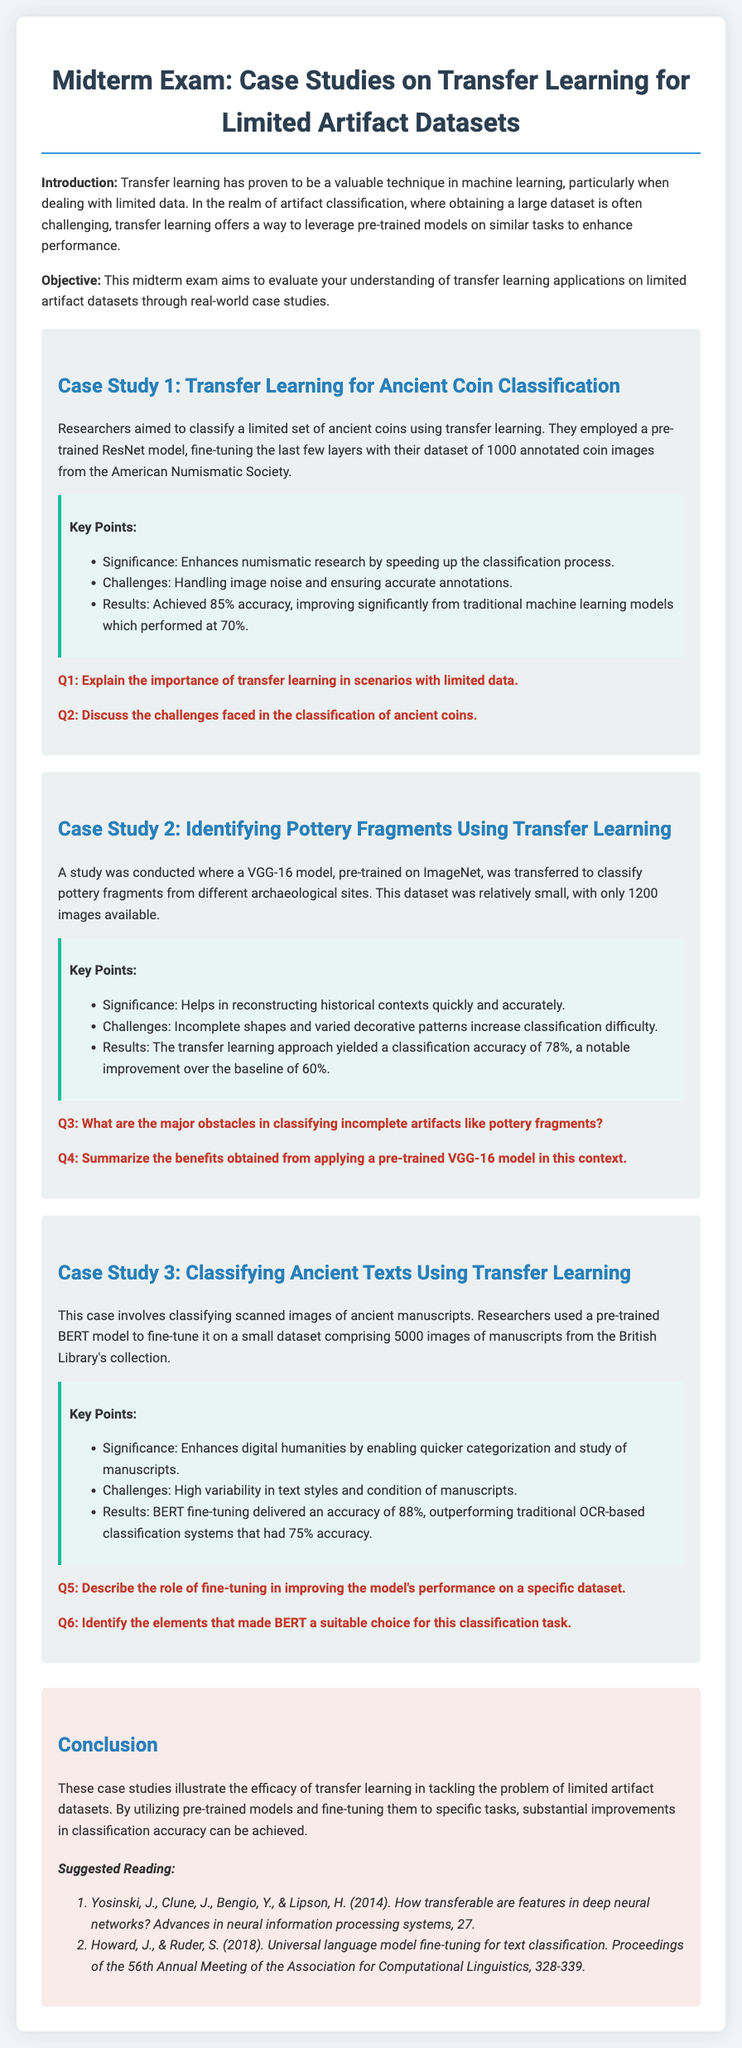What model was used for ancient coin classification? The researchers employed a pre-trained ResNet model for classifying ancient coins.
Answer: ResNet What was the accuracy achieved in the ancient coin classification study? The study achieved an accuracy of 85% in classifying the ancient coins.
Answer: 85% How many images were in the pottery fragments dataset? The pottery fragments dataset comprised only 1200 images for classification.
Answer: 1200 What was the baseline accuracy for the VGG-16 model used on pottery fragments? The baseline accuracy for the VGG-16 model was noted to be 60%.
Answer: 60% What dataset size was used for fine-tuning the BERT model in ancient text classification? The dataset used for fine-tuning the BERT model consisted of 5000 images.
Answer: 5000 What issue complicates the classification of pottery fragments? Incomplete shapes and varied decorative patterns were significant challenges in classifying pottery fragments.
Answer: Incomplete shapes and varied decorative patterns What pre-trained model was used for classifying ancient manuscripts? Researchers used a pre-trained BERT model for classifying ancient manuscripts.
Answer: BERT What classification accuracy did fine-tuning BERT achieve? Fine-tuning BERT delivered an accuracy of 88% for the manuscript classification task.
Answer: 88% What is the significance of transfer learning in artifact classification? Transfer learning is significant as it enhances performance on limited datasets by leveraging pre-trained models.
Answer: Enhances performance on limited datasets 